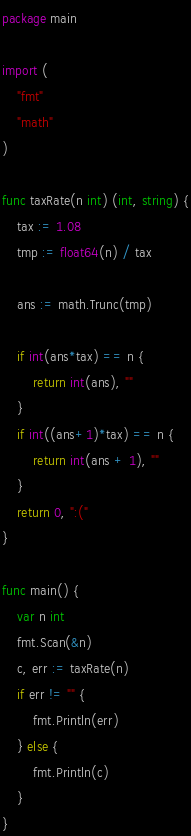Convert code to text. <code><loc_0><loc_0><loc_500><loc_500><_Go_>package main

import (
	"fmt"
	"math"
)

func taxRate(n int) (int, string) {
	tax := 1.08
	tmp := float64(n) / tax

	ans := math.Trunc(tmp)

	if int(ans*tax) == n {
		return int(ans), ""
	}
	if int((ans+1)*tax) == n {
		return int(ans + 1), ""
	}
	return 0, ":("
}

func main() {
	var n int
	fmt.Scan(&n)
	c, err := taxRate(n)
	if err != "" {
		fmt.Println(err)
	} else {
		fmt.Println(c)
	}
}
</code> 